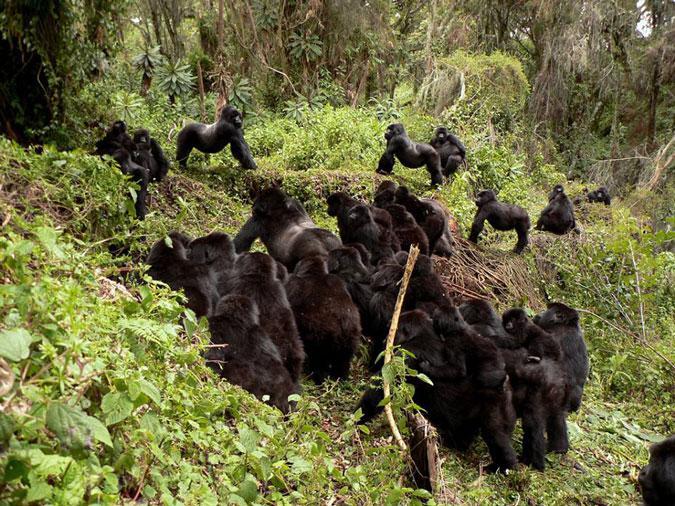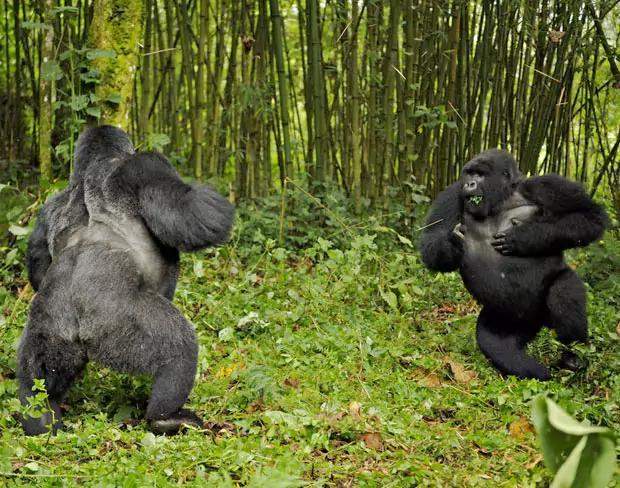The first image is the image on the left, the second image is the image on the right. Examine the images to the left and right. Is the description "At least one image contains no more than two gorillas and contains at least one adult male." accurate? Answer yes or no. Yes. The first image is the image on the left, the second image is the image on the right. Examine the images to the left and right. Is the description "There are no more than two gorillas in the right image." accurate? Answer yes or no. Yes. 